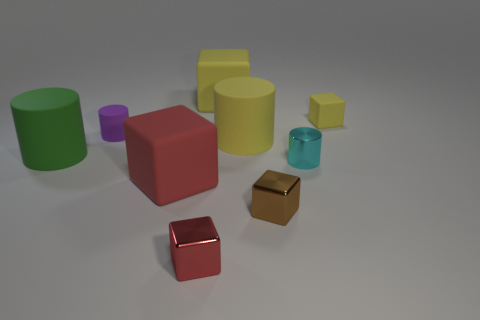Subtract all blue cylinders. How many yellow cubes are left? 2 Subtract all yellow blocks. How many blocks are left? 3 Subtract all purple cylinders. How many cylinders are left? 3 Subtract all purple cylinders. Subtract all brown blocks. How many cylinders are left? 3 Add 7 big rubber cubes. How many big rubber cubes exist? 9 Subtract 0 green cubes. How many objects are left? 9 Subtract all blocks. How many objects are left? 4 Subtract 1 cylinders. How many cylinders are left? 3 Subtract all brown objects. Subtract all small purple rubber cylinders. How many objects are left? 7 Add 9 big red rubber objects. How many big red rubber objects are left? 10 